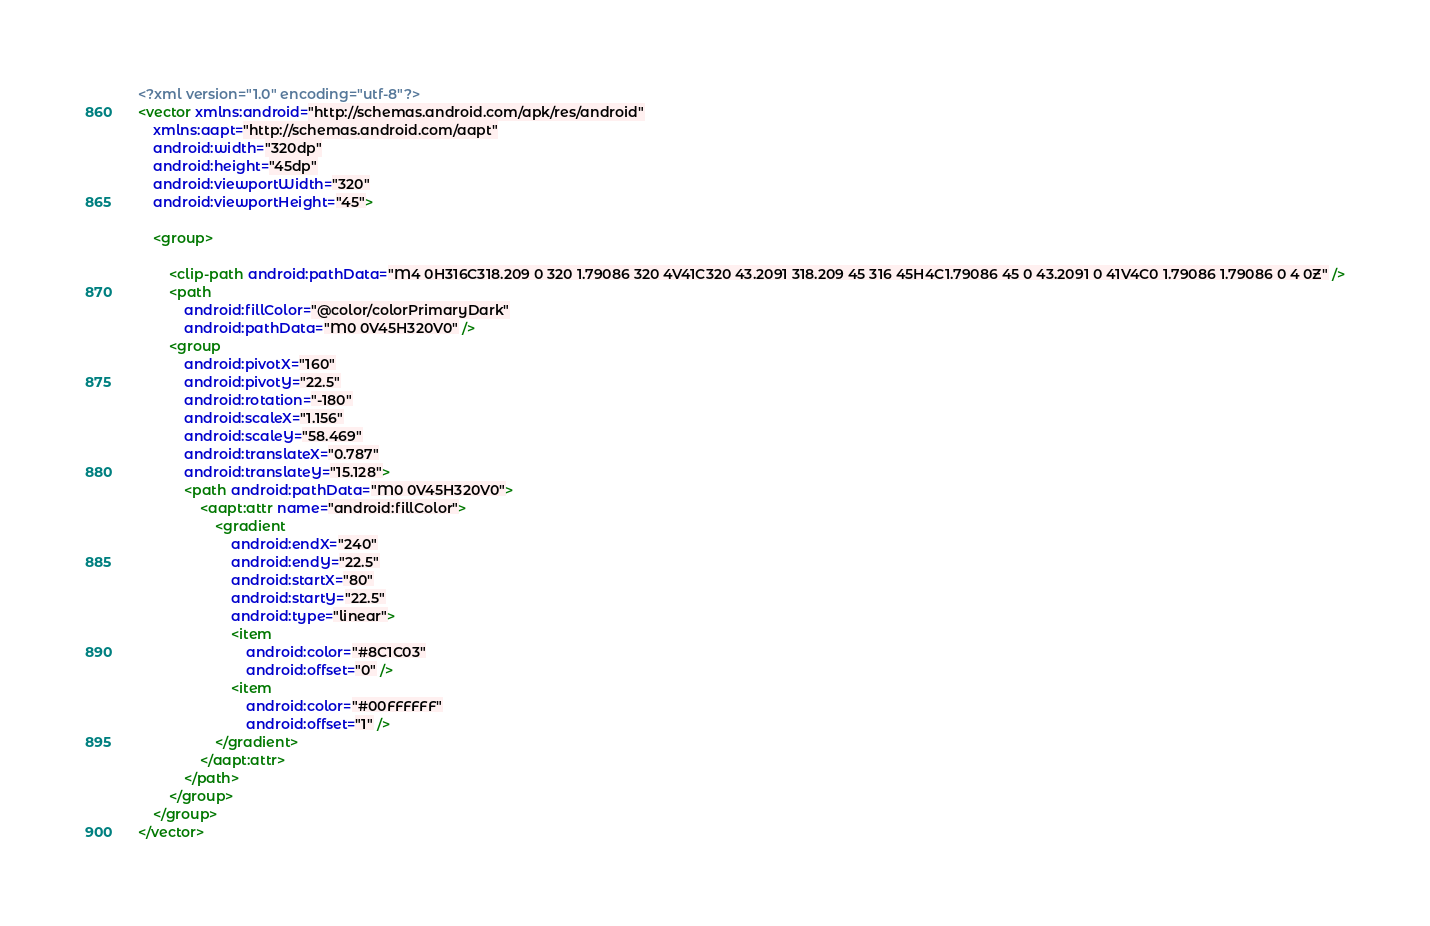<code> <loc_0><loc_0><loc_500><loc_500><_XML_><?xml version="1.0" encoding="utf-8"?>
<vector xmlns:android="http://schemas.android.com/apk/res/android"
    xmlns:aapt="http://schemas.android.com/aapt"
    android:width="320dp"
    android:height="45dp"
    android:viewportWidth="320"
    android:viewportHeight="45">

    <group>

        <clip-path android:pathData="M4 0H316C318.209 0 320 1.79086 320 4V41C320 43.2091 318.209 45 316 45H4C1.79086 45 0 43.2091 0 41V4C0 1.79086 1.79086 0 4 0Z" />
        <path
            android:fillColor="@color/colorPrimaryDark"
            android:pathData="M0 0V45H320V0" />
        <group
            android:pivotX="160"
            android:pivotY="22.5"
            android:rotation="-180"
            android:scaleX="1.156"
            android:scaleY="58.469"
            android:translateX="0.787"
            android:translateY="15.128">
            <path android:pathData="M0 0V45H320V0">
                <aapt:attr name="android:fillColor">
                    <gradient
                        android:endX="240"
                        android:endY="22.5"
                        android:startX="80"
                        android:startY="22.5"
                        android:type="linear">
                        <item
                            android:color="#8C1C03"
                            android:offset="0" />
                        <item
                            android:color="#00FFFFFF"
                            android:offset="1" />
                    </gradient>
                </aapt:attr>
            </path>
        </group>
    </group>
</vector>
</code> 